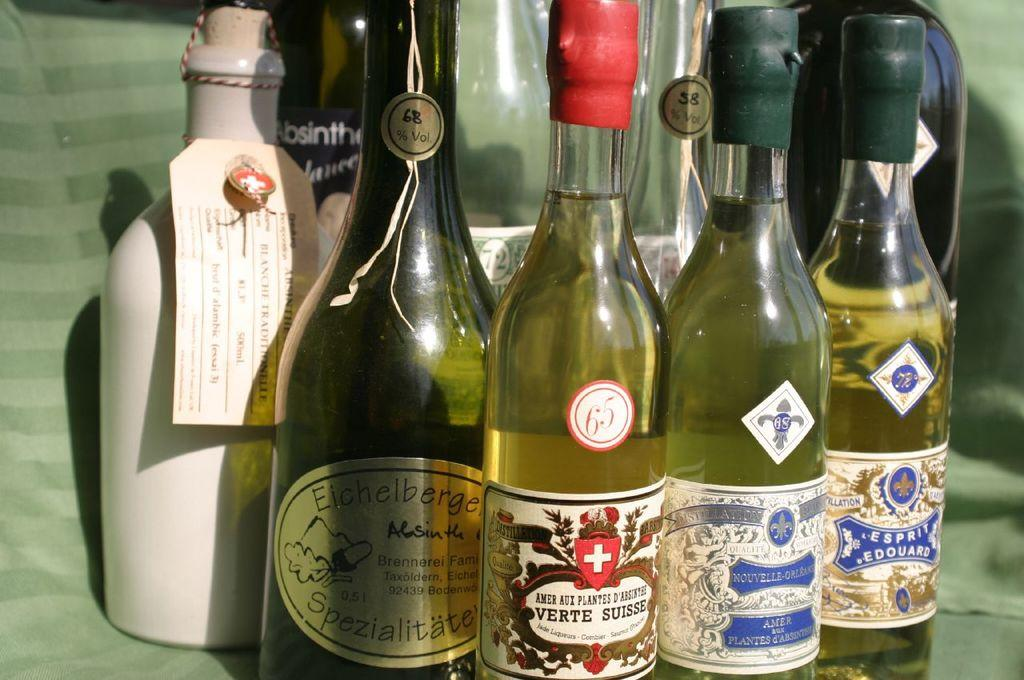What objects can be seen in the image? There are bottles in the image. What information is provided on the bottles? The bottles are labeled as 'SPECIALIZED'. What is the surface on which the bottles are placed? The bottles are placed on a green color mat. What type of oil can be seen dripping from the bottles in the image? There is no oil present in the image, and the bottles are not depicted as dripping any substance. 